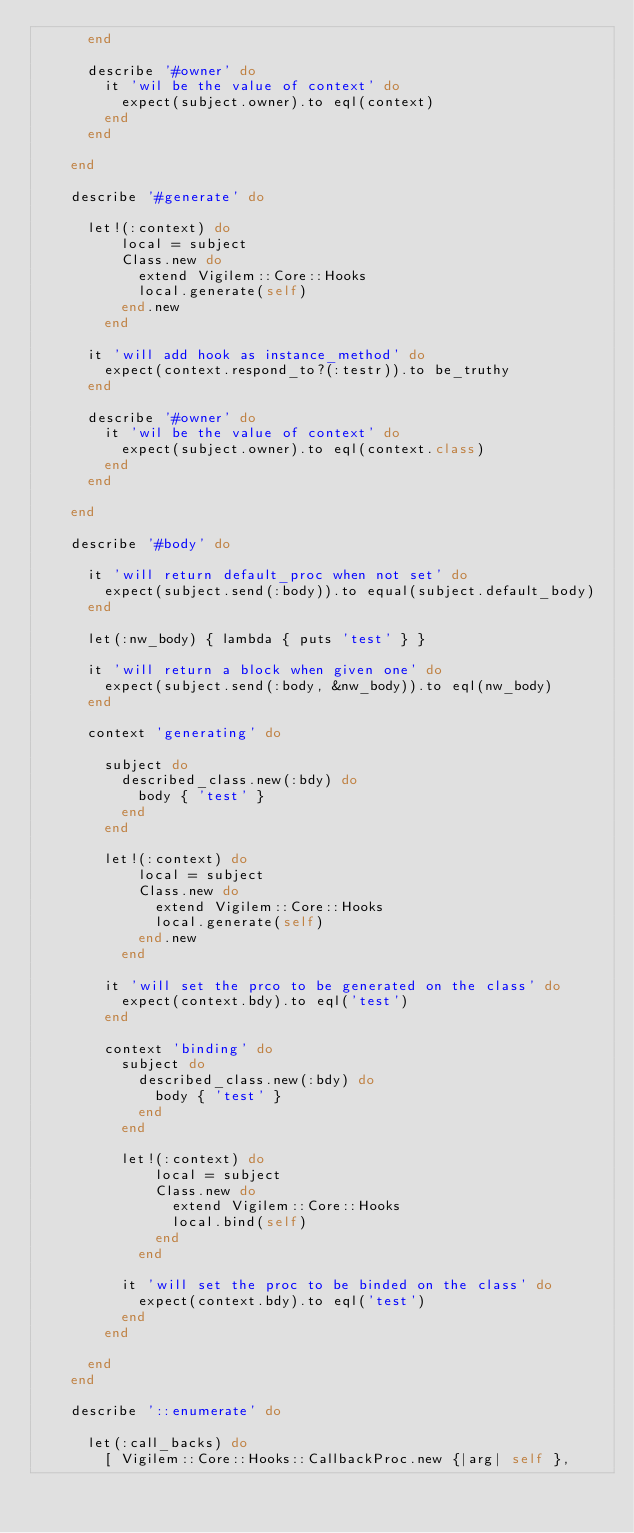Convert code to text. <code><loc_0><loc_0><loc_500><loc_500><_Ruby_>      end
      
      describe '#owner' do
        it 'wil be the value of context' do
          expect(subject.owner).to eql(context)
        end
      end
      
    end
    
    describe '#generate' do
    
      let!(:context) do
          local = subject
          Class.new do 
            extend Vigilem::Core::Hooks
            local.generate(self)
          end.new
        end
      
      it 'will add hook as instance_method' do
        expect(context.respond_to?(:testr)).to be_truthy
      end
      
      describe '#owner' do
        it 'wil be the value of context' do
          expect(subject.owner).to eql(context.class)
        end
      end
      
    end
    
    describe '#body' do
      
      it 'will return default_proc when not set' do
        expect(subject.send(:body)).to equal(subject.default_body)
      end
      
      let(:nw_body) { lambda { puts 'test' } }
      
      it 'will return a block when given one' do
        expect(subject.send(:body, &nw_body)).to eql(nw_body)
      end
      
      context 'generating' do
        
        subject do
          described_class.new(:bdy) do
            body { 'test' }
          end
        end
        
        let!(:context) do
            local = subject
            Class.new do 
              extend Vigilem::Core::Hooks
              local.generate(self)
            end.new
          end
        
        it 'will set the prco to be generated on the class' do
          expect(context.bdy).to eql('test')
        end
        
        context 'binding' do
          subject do
            described_class.new(:bdy) do
              body { 'test' }
            end
          end
          
          let!(:context) do
              local = subject
              Class.new do 
                extend Vigilem::Core::Hooks
                local.bind(self)
              end
            end
          
          it 'will set the proc to be binded on the class' do
            expect(context.bdy).to eql('test')
          end
        end
        
      end
    end
    
    describe '::enumerate' do
      
      let(:call_backs) do 
        [ Vigilem::Core::Hooks::CallbackProc.new {|arg| self }, </code> 